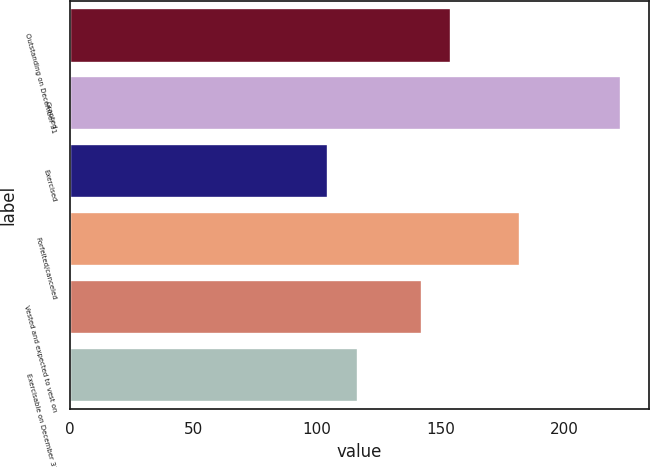<chart> <loc_0><loc_0><loc_500><loc_500><bar_chart><fcel>Outstanding on December 31<fcel>Granted<fcel>Exercised<fcel>Forfeited/canceled<fcel>Vested and expected to vest on<fcel>Exercisable on December 31<nl><fcel>154.18<fcel>223.06<fcel>104.48<fcel>182.08<fcel>142.32<fcel>116.34<nl></chart> 